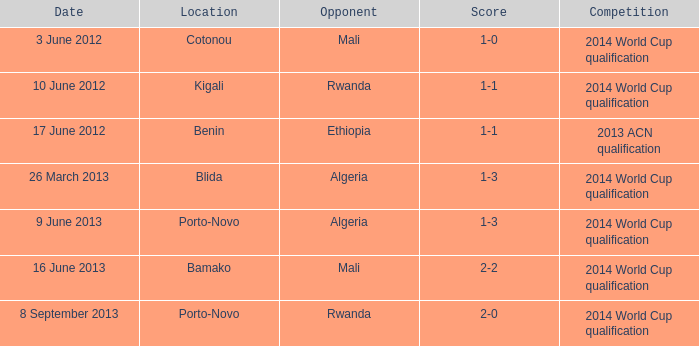What competition is located in bamako? 2014 World Cup qualification. 